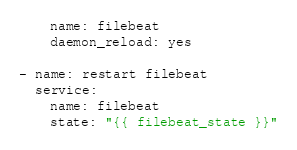Convert code to text. <code><loc_0><loc_0><loc_500><loc_500><_YAML_>    name: filebeat
    daemon_reload: yes

- name: restart filebeat
  service:
    name: filebeat
    state: "{{ filebeat_state }}"
</code> 